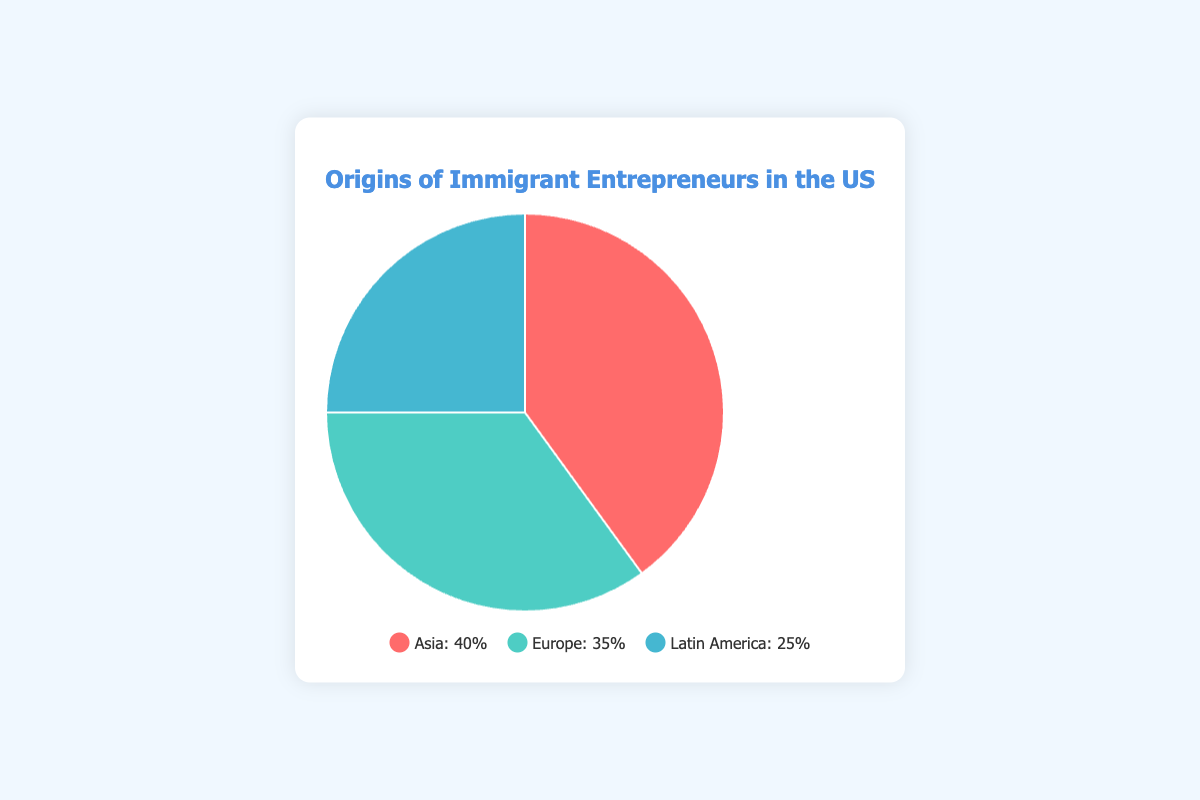What region has the highest percentage of immigrant entrepreneurs in the US? The chart shows three regions with respective percentages: Asia (40%), Europe (35%), and Latin America (25%). By comparing these values, Asia has the highest percentage at 40%.
Answer: Asia Which region has the smallest share of immigrant entrepreneurs? The chart shows Asia at 40%, Europe at 35%, and Latin America at 25%. The smallest percentage is 25%, which corresponds to Latin America.
Answer: Latin America What is the difference in percentage between Asian and European immigrant entrepreneurs? The chart shows Asian entrepreneurs at 40% and European entrepreneurs at 35%. The difference between these values is 40% - 35% = 5%.
Answer: 5% What percentage of immigrant entrepreneurs come from regions other than Asia? The chart shows Asia at 40%, Europe at 35%, and Latin America at 25%. To find the percentage for regions other than Asia, sum Europe and Latin America's percentages: 35% + 25% = 60%.
Answer: 60% If an immigrant entrepreneur is randomly selected, what is the probability that they are from either Europe or Latin America? The chart shows Europe at 35% and Latin America at 25%. The combined probability of selecting an entrepreneur from either region is their combined percentage: 35% + 25% = 60%.
Answer: 60% By how much does the percentage of immigrant entrepreneurs from Europe exceed those from Latin America? From the chart, Europe has 35% and Latin America has 25%. The difference between these values is 35% - 25% = 10%.
Answer: 10% What is the total percentage of immigrant entrepreneurs from all the regions combined? The chart shows the percentages for Asia (40%), Europe (35%), and Latin America (25%). Summing these percentages gives 40% + 35% + 25% = 100%.
Answer: 100% Which region is represented by the green segment in the pie chart? Typically, the legend or visual representation in the pie chart will indicate that the green segment corresponds to a particular region. According to the color-coding from the question context, Europe is shown in green.
Answer: Europe 